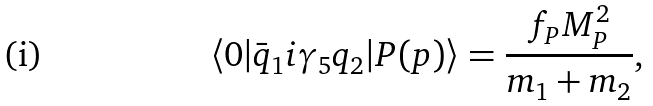Convert formula to latex. <formula><loc_0><loc_0><loc_500><loc_500>\langle 0 | \bar { q } _ { 1 } i \gamma _ { 5 } q _ { 2 } | P ( p ) \rangle = \frac { f _ { P } M ^ { 2 } _ { P } } { m _ { 1 } + m _ { 2 } } , \</formula> 